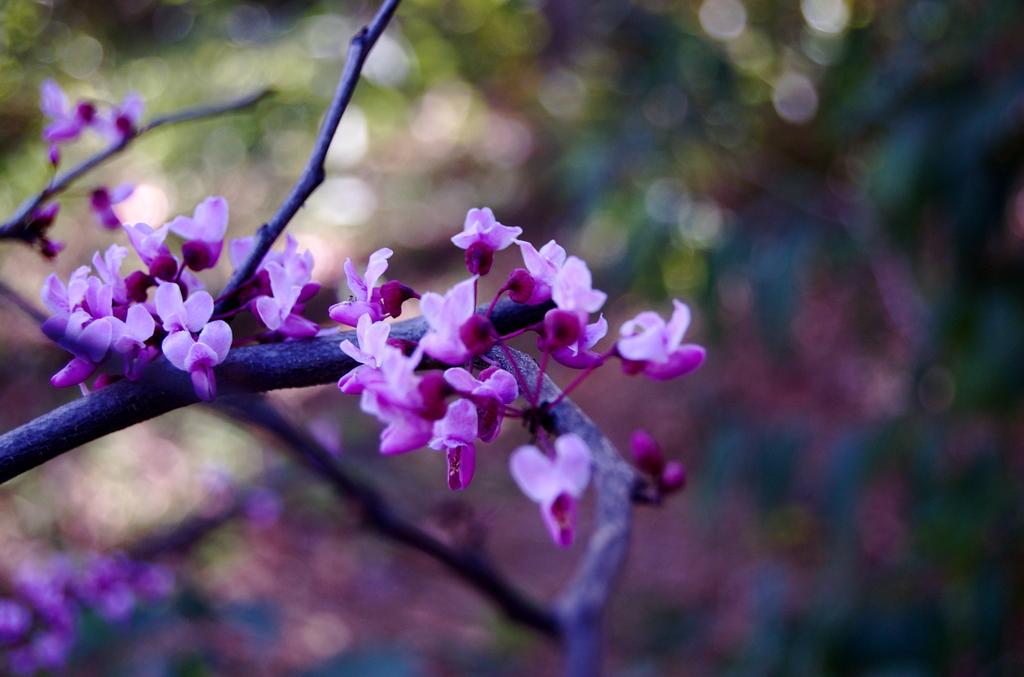What type of plants can be seen in the image? There are flowers in the image. Where are the flowers located? The flowers are on a branch. Can you describe the background of the image? The background of the image is blurred. How many mouths can be seen on the flowers in the image? There are no mouths present on the flowers in the image, as flowers do not have mouths. 